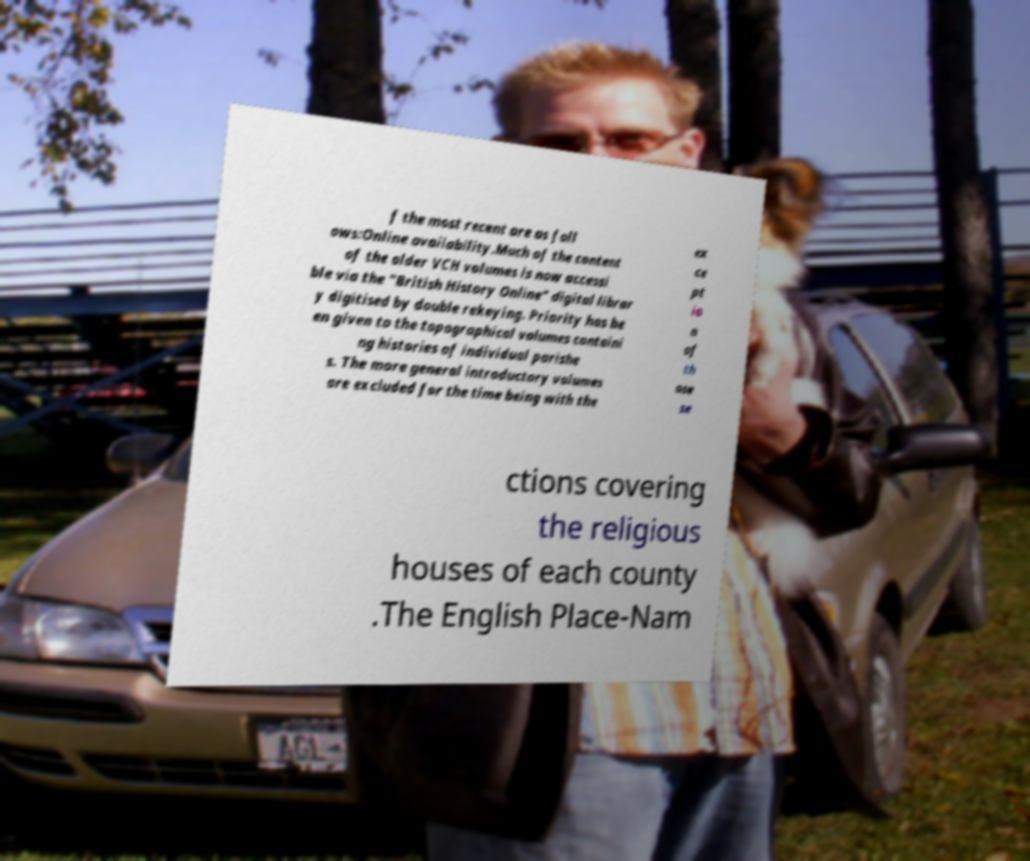I need the written content from this picture converted into text. Can you do that? f the most recent are as foll ows:Online availability.Much of the content of the older VCH volumes is now accessi ble via the "British History Online" digital librar y digitised by double rekeying. Priority has be en given to the topographical volumes containi ng histories of individual parishe s. The more general introductory volumes are excluded for the time being with the ex ce pt io n of th ose se ctions covering the religious houses of each county .The English Place-Nam 